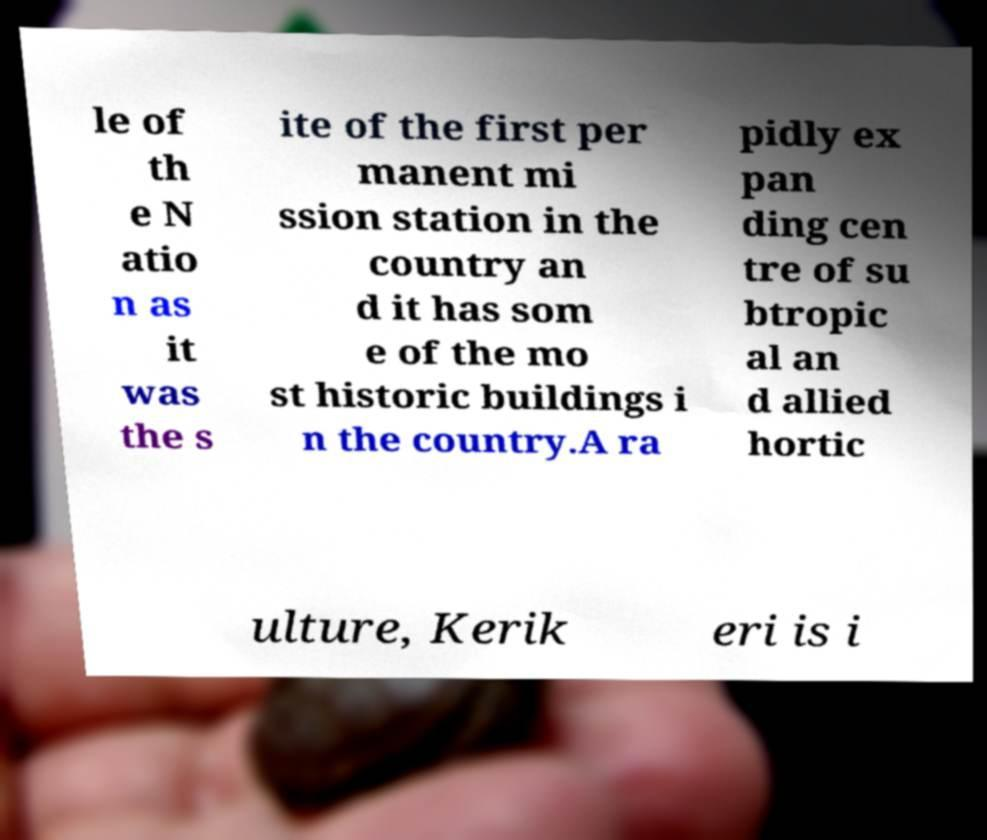What messages or text are displayed in this image? I need them in a readable, typed format. le of th e N atio n as it was the s ite of the first per manent mi ssion station in the country an d it has som e of the mo st historic buildings i n the country.A ra pidly ex pan ding cen tre of su btropic al an d allied hortic ulture, Kerik eri is i 